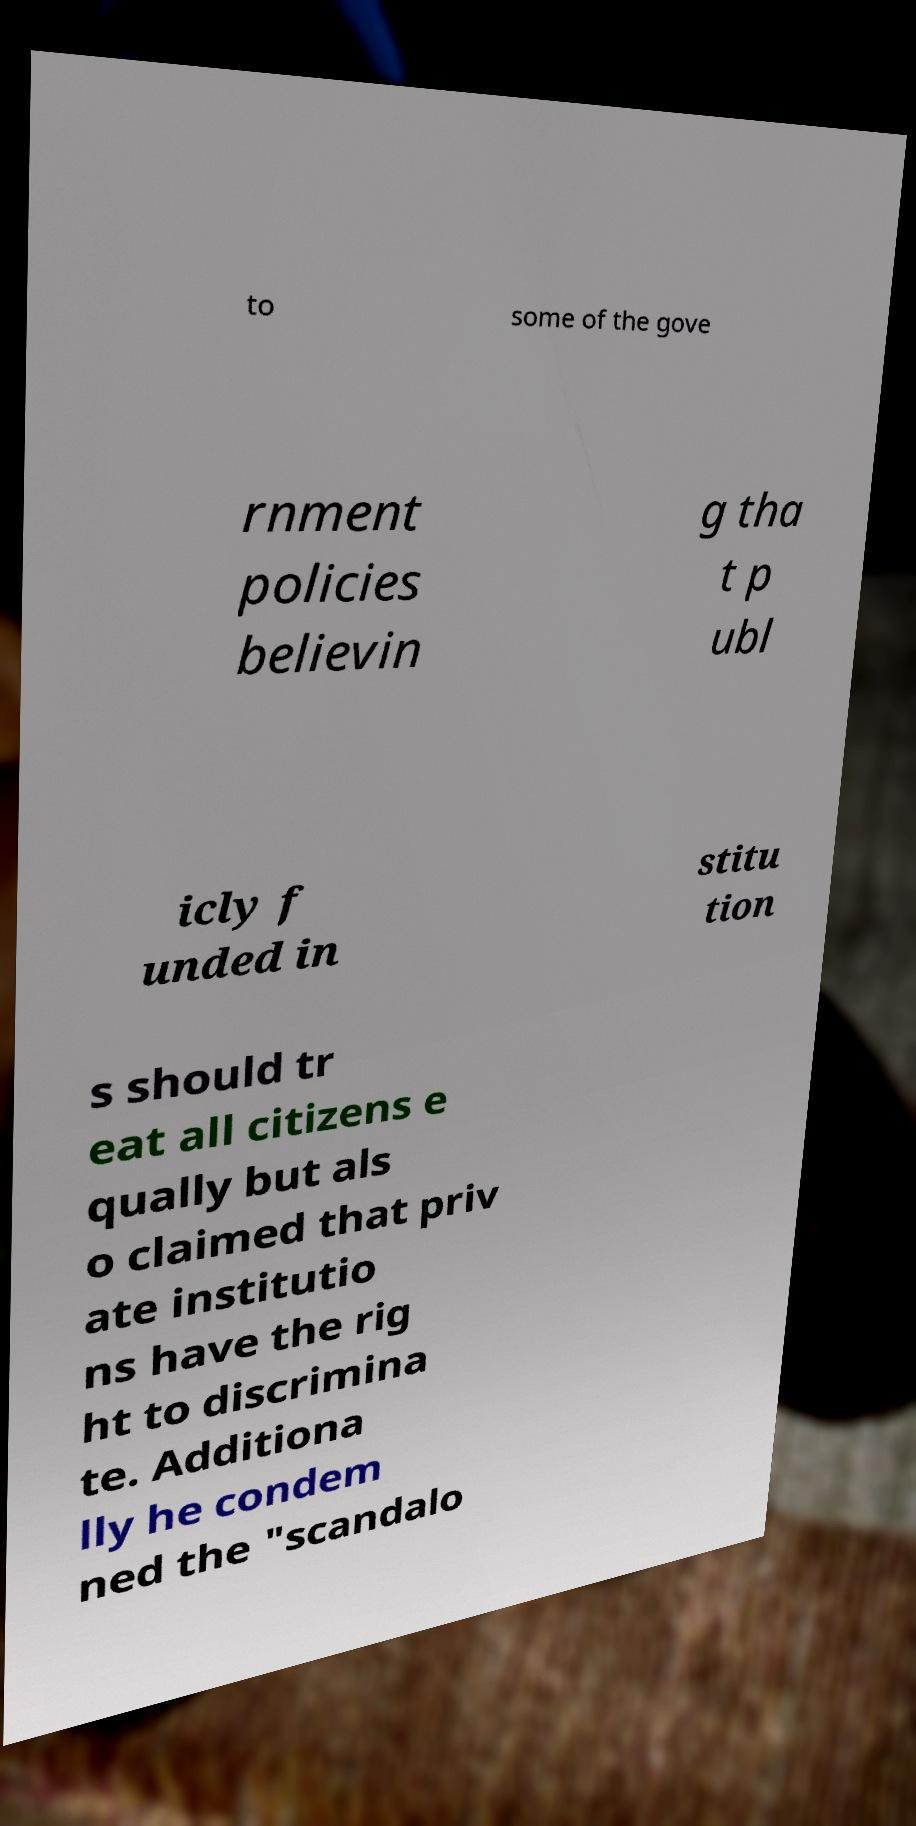Please read and relay the text visible in this image. What does it say? to some of the gove rnment policies believin g tha t p ubl icly f unded in stitu tion s should tr eat all citizens e qually but als o claimed that priv ate institutio ns have the rig ht to discrimina te. Additiona lly he condem ned the "scandalo 